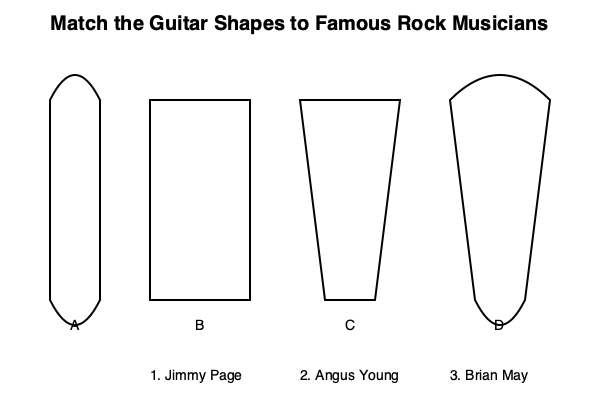Match the guitar shapes (A-D) to the corresponding famous rock musicians (1-3). Which shape is associated with the guitarist known for his iconic double-neck guitar? To answer this question, let's analyze each guitar shape and musician:

1. Shape A: This curved shape resembles a Gibson Les Paul, famously used by Jimmy Page of Led Zeppelin.

2. Shape B: This rectangular shape represents a Gibson SG, the signature guitar of Angus Young from AC/DC.

3. Shape C: This trapezoid shape doesn't correspond to any of the listed musicians' signature guitars.

4. Shape D: This unique shape resembles the Red Special, the homemade guitar of Brian May from Queen.

5. Jimmy Page (1) is known for playing various guitars, but he's particularly associated with the Gibson Les Paul (Shape A) and a double-neck Gibson EDS-1275.

6. Angus Young (2) is instantly recognizable with his Gibson SG (Shape B).

7. Brian May (3) exclusively plays his Red Special guitar (Shape D).

8. The question specifically asks about the guitarist known for his iconic double-neck guitar. This refers to Jimmy Page, who famously used a double-neck Gibson EDS-1275 for live performances of "Stairway to Heaven."

9. Although the double-neck guitar isn't shown in the diagram, Jimmy Page is associated with Shape A (Gibson Les Paul).

Therefore, the shape associated with the guitarist known for his iconic double-neck guitar is Shape A.
Answer: A 